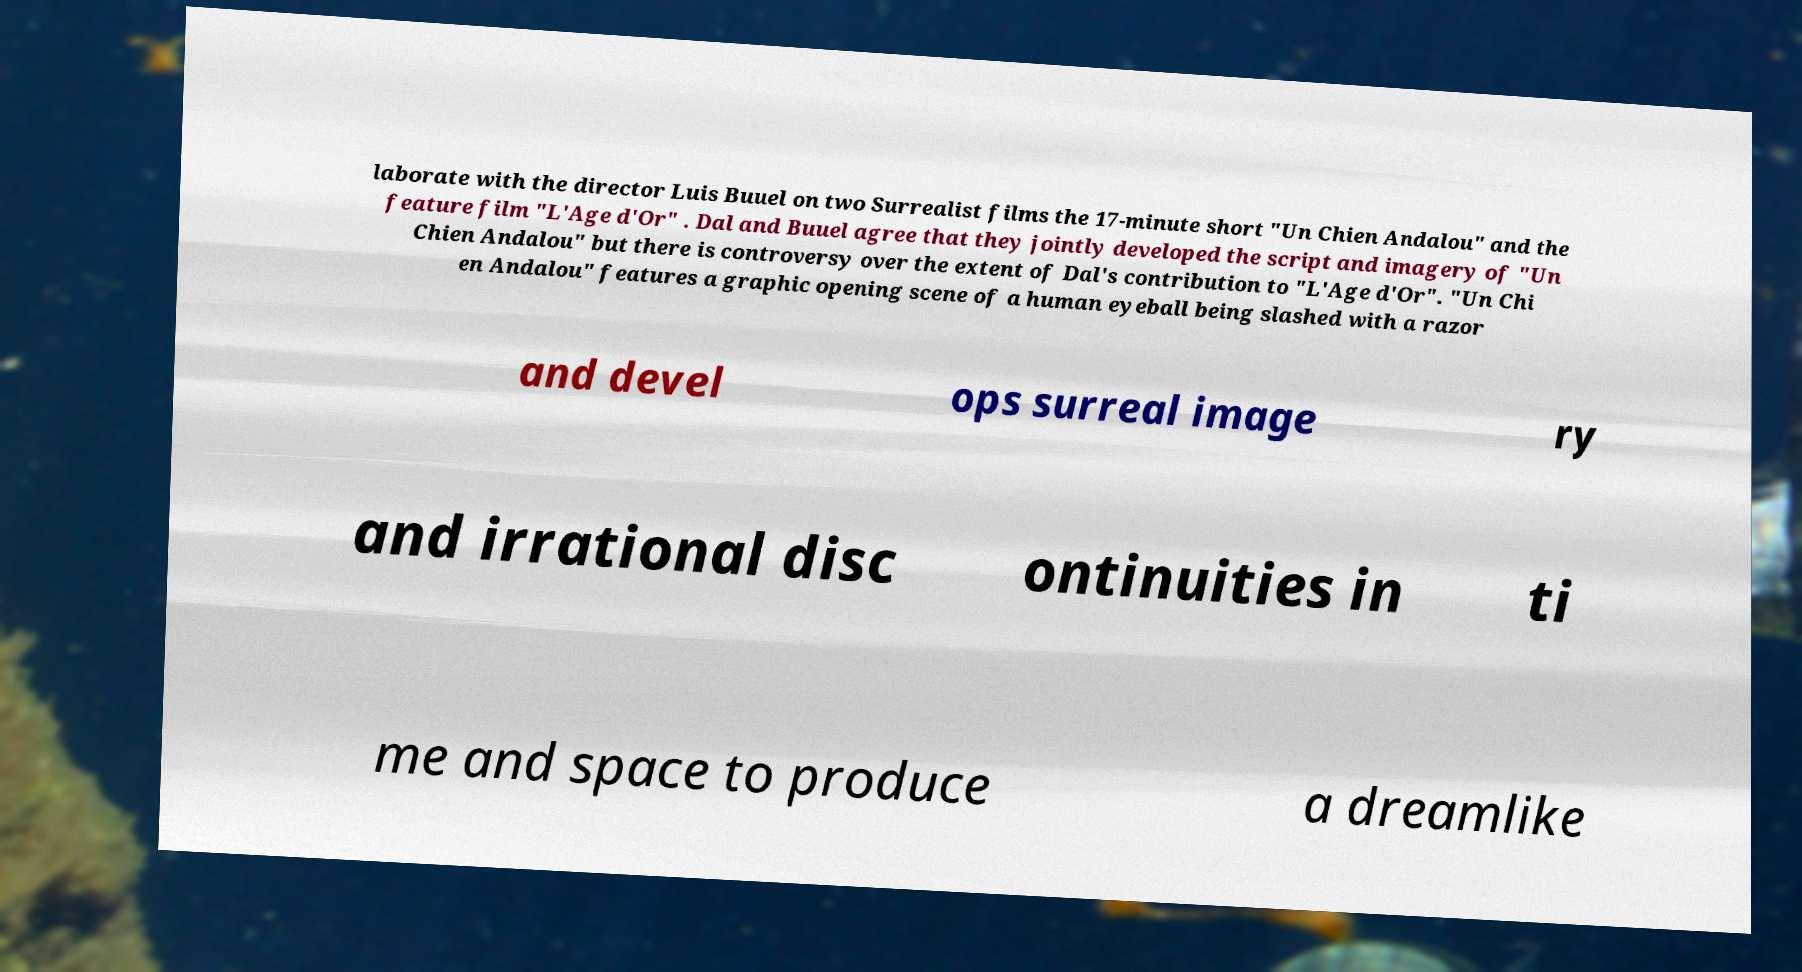Could you extract and type out the text from this image? laborate with the director Luis Buuel on two Surrealist films the 17-minute short "Un Chien Andalou" and the feature film "L'Age d'Or" . Dal and Buuel agree that they jointly developed the script and imagery of "Un Chien Andalou" but there is controversy over the extent of Dal's contribution to "L'Age d'Or". "Un Chi en Andalou" features a graphic opening scene of a human eyeball being slashed with a razor and devel ops surreal image ry and irrational disc ontinuities in ti me and space to produce a dreamlike 